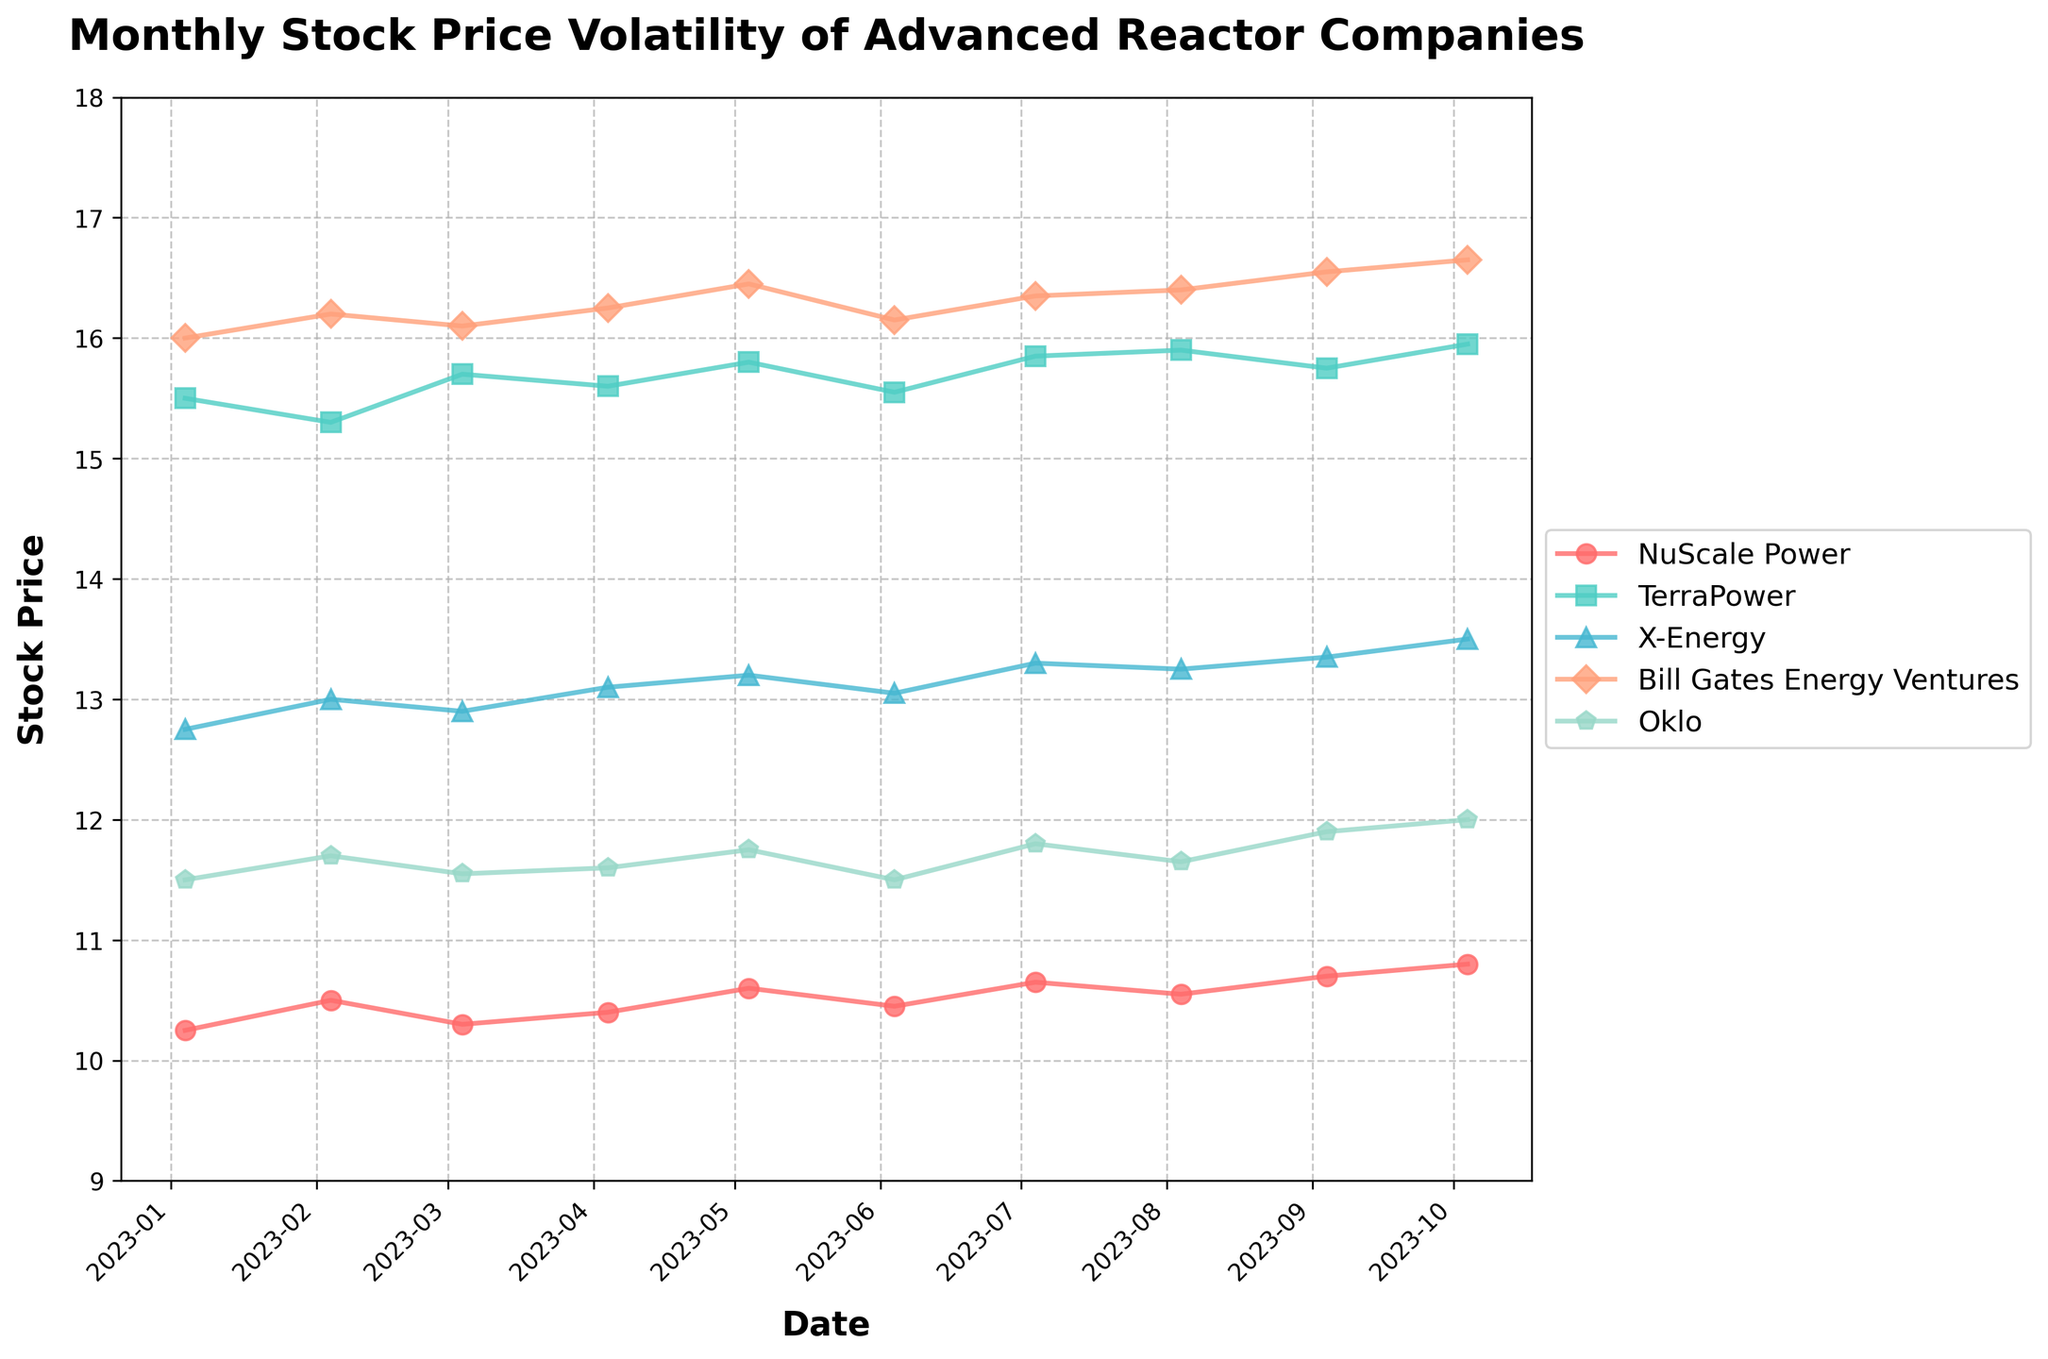What is the title of the plot? The title of the plot is located at the top center and reads: "Monthly Stock Price Volatility of Advanced Reactor Companies."
Answer: Monthly Stock Price Volatility of Advanced Reactor Companies Which company has the highest stock price in August 2023? By examining the plotted stock prices for August 2023, we see that "Bill Gates Energy Ventures" has the highest stock price for that month.
Answer: Bill Gates Energy Ventures What is the range of the y-axis? The y-axis labels indicate that the range of stock prices spans from 9 to 18.
Answer: 9 to 18 Which company showed the greatest increase in stock price from January 2023 to October 2023? By comparing the starting and ending stock prices for each company from January 2023 to October 2023, "NuScale Power" increased from 10.25 to 10.80, "TerraPower" from 15.50 to 15.95, "X-Energy" from 12.75 to 13.50, "Bill Gates Energy Ventures" from 16.00 to 16.65, and "Oklo" from 11.50 to 12.00. "Bill Gates Energy Ventures" shows the greatest increase.
Answer: Bill Gates Energy Ventures What is the average stock price of Oklo over the 10 months shown? Adding the monthly stock prices of Oklo (11.50, 11.70, 11.55, 11.60, 11.75, 11.50, 11.80, 11.65, 11.90, 12.00) and dividing by 10, we get the average: (11.50 + 11.70 + 11.55 + 11.60 + 11.75 + 11.50 + 11.80 + 11.65 + 11.90 + 12.00) / 10 = 11.695.
Answer: 11.695 Which month shows the least variation in stock prices between the given companies? By visually comparing the lines for each month, we see that April 2023 has the smallest variation, as the stock prices for "NuScale Power" (10.40), "TerraPower" (15.60), "X-Energy" (13.10), "Bill Gates Energy Ventures" (16.25), and "Oklo" (11.60) are closer in value compared to other months.
Answer: April 2023 How many companies show a stock price above 15.00 in October 2023? By looking at the stock prices in October 2023, "TerraPower" (15.95), "Bill Gates Energy Ventures" (16.65), and "X-Energy" (13.50) are considered, but only "TerraPower" and "Bill Gates Energy Ventures" have stock prices above 15.00.
Answer: Two Which company had the most stable stock price over the 10-month period? By examining the volatility of each company's stock prices, "NuScale Power" displays the least variation, with values ranging from 10.25 to 10.80.
Answer: NuScale Power Which companies had a higher stock price in September 2023 compared to March 2023? Comparing the stock prices of March and September, "NuScale Power" (10.30 to 10.70), "X-Energy" (12.90 to 13.35), "Bill Gates Energy Ventures" (16.10 to 16.55), and "Oklo" (11.55 to 11.90) show an increase, while "TerraPower" decreased slightly.
Answer: NuScale Power, X-Energy, Bill Gates Energy Ventures, Oklo 